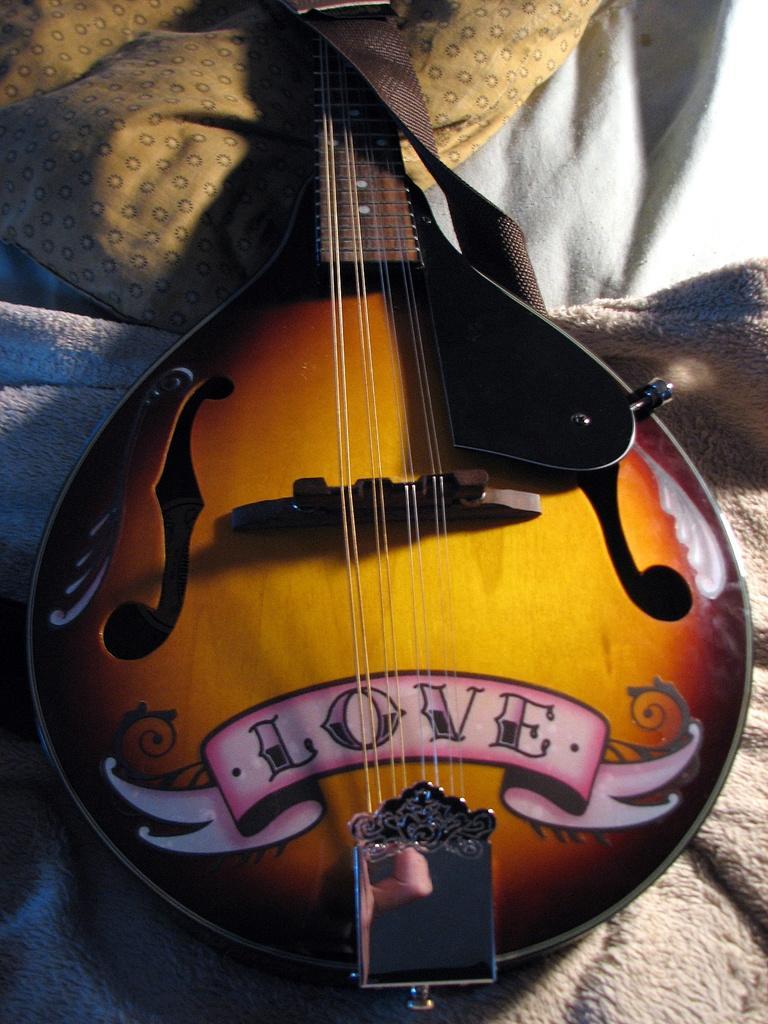Could you give a brief overview of what you see in this image? In this image, in the middle there is a guitar which is in yellow color, and there is a yellow color bag. 